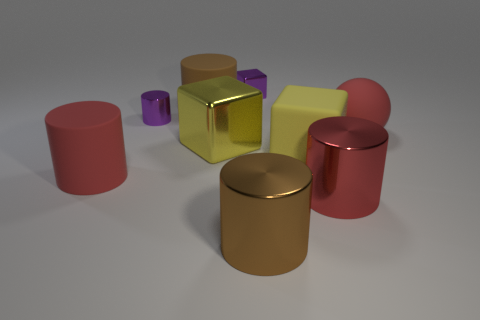How does the lighting affect the appearance of the objects? The lighting in the image creates soft shadows and highlights that define the shapes of the objects. It brings out the shininess of the reflective materials and gives a sense of depth and dimension to the composition. 